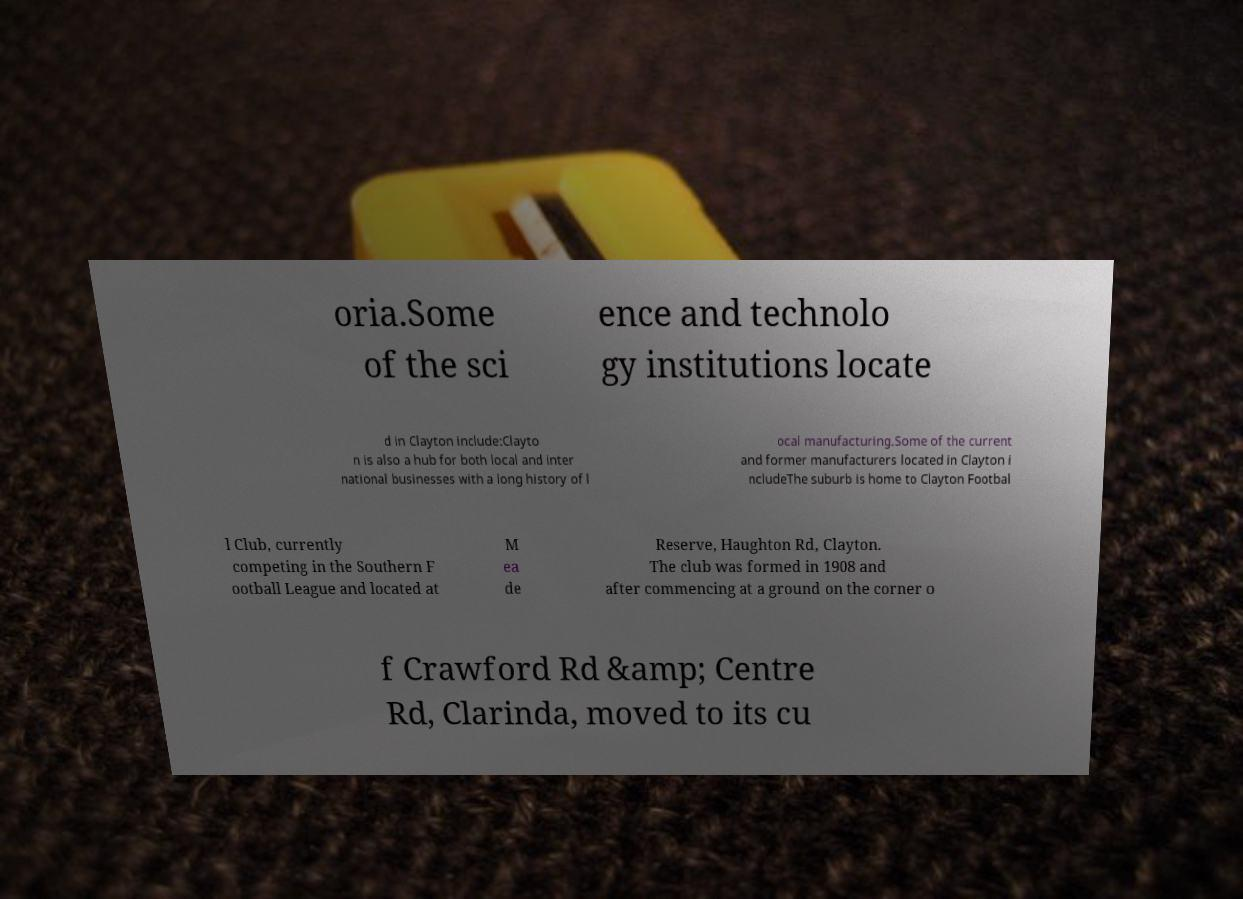Could you assist in decoding the text presented in this image and type it out clearly? oria.Some of the sci ence and technolo gy institutions locate d in Clayton include:Clayto n is also a hub for both local and inter national businesses with a long history of l ocal manufacturing.Some of the current and former manufacturers located in Clayton i ncludeThe suburb is home to Clayton Footbal l Club, currently competing in the Southern F ootball League and located at M ea de Reserve, Haughton Rd, Clayton. The club was formed in 1908 and after commencing at a ground on the corner o f Crawford Rd &amp; Centre Rd, Clarinda, moved to its cu 